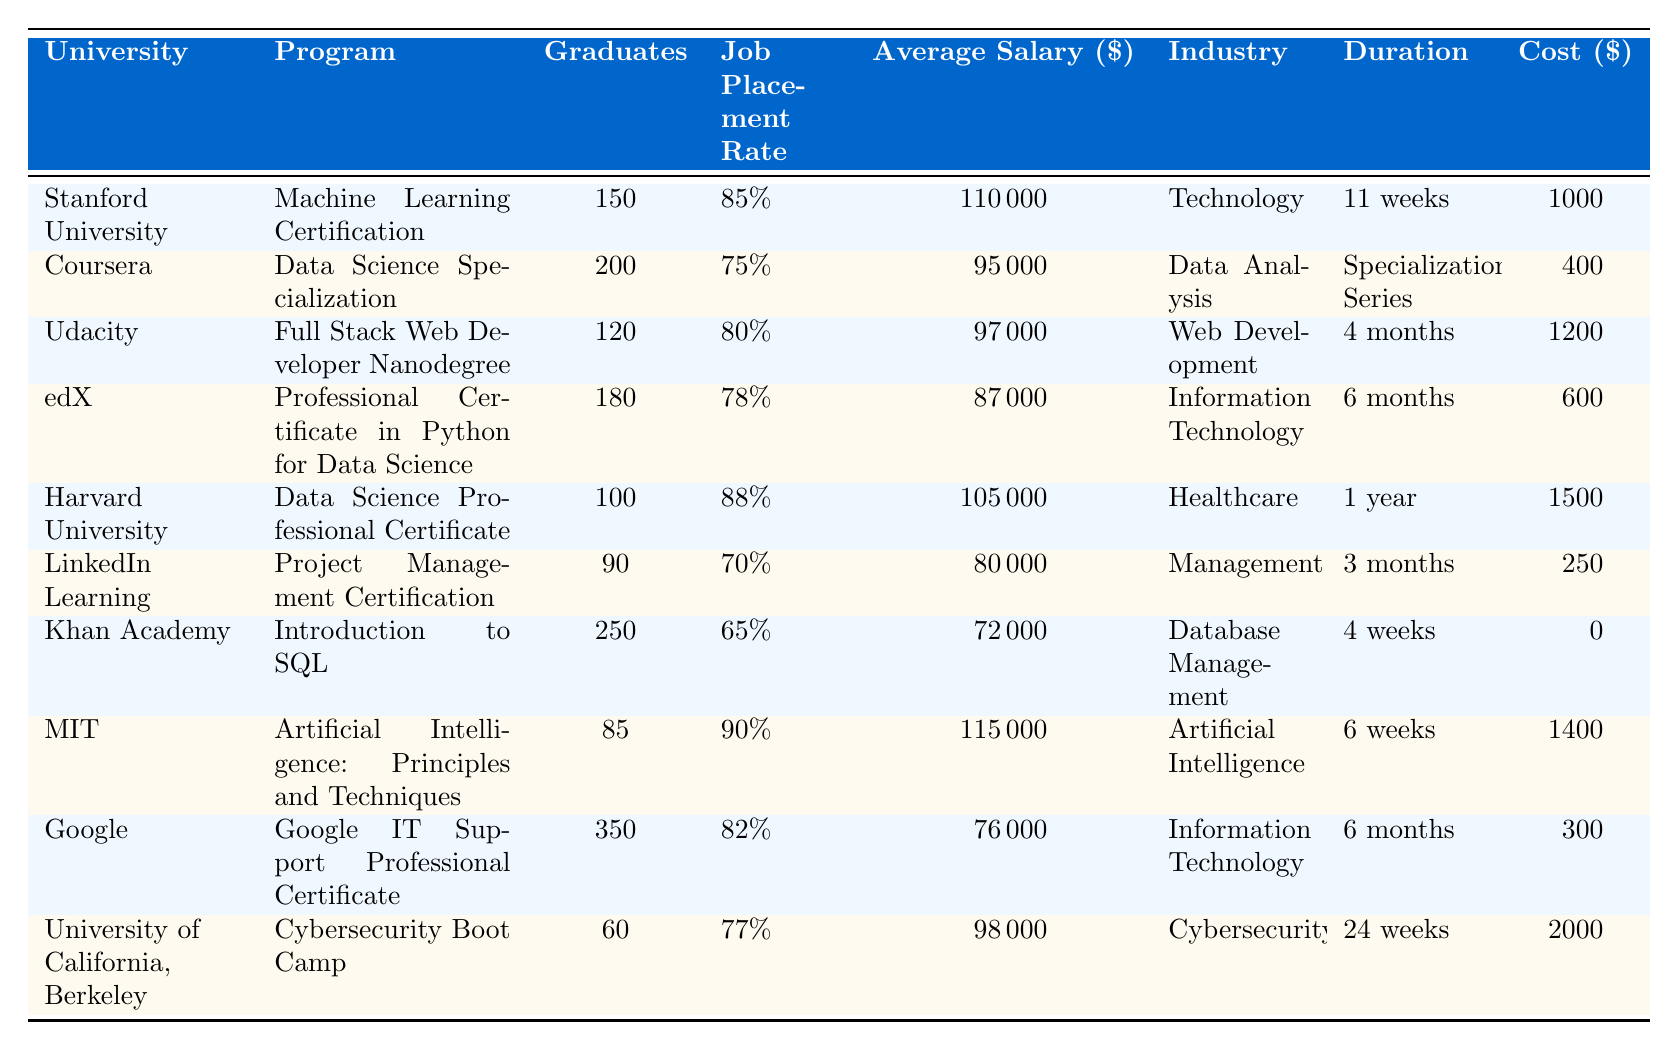What is the job placement rate for the Machine Learning Certification program? The job placement rate for the Machine Learning Certification program at Stanford University can be found directly in the corresponding row of the table, which states the rate is 85%.
Answer: 85% Which program has the highest average salary? By reviewing the average salaries across all programs, the highest one is for the Artificial Intelligence program at MIT, which is $115,000.
Answer: $115,000 What is the average job placement rate for the programs offered by edX and LinkedIn Learning? The job placement rates for edX and LinkedIn Learning are 78% and 70%, respectively. To find the average, we add them together (78 + 70 = 148) and then divide by 2, resulting in 74%.
Answer: 74% Is the duration of the Data Science Specialization longer than that of the Machine Learning Certification? The duration of the Data Science Specialization is listed as a "Specialization Series," while the Machine Learning Certification is 11 weeks. Without a specific week count for the Specialization, we cannot definitively compare these durations. Therefore, the answer is no, we cannot confirm that it is longer.
Answer: No How many graduates are there from the Google IT Support Professional Certificate program, and how does that compare to the Harvard Data Science Professional Certificate? The Google IT Support Professional Certificate has 350 graduates, while the Harvard Data Science Professional Certificate has 100 graduates. This shows that Google’s program has 250 more graduates than Harvard's.
Answer: 350 graduates (250 more than Harvard) What percentage of graduates from the Cybersecurity Boot Camp were placed in jobs? From the table, the job placement rate for the Cybersecurity Boot Camp is listed as 77%.
Answer: 77% What is the cost difference between the Cybersecurity Boot Camp and the Data Science Specialization? The cost of the Cybersecurity Boot Camp is $2000 and the Data Science Specialization is $400. The difference is calculated as $2000 - $400 = $1600.
Answer: $1600 Which industry has the lowest job placement rate and what is that rate? The table shows that the program with the lowest job placement rate is "Introduction to SQL" at Khan Academy with a rate of 65%.
Answer: 65% If you combine the number of graduates from the Machine Learning Certification and the Full Stack Web Developer Nanodegree, what is the total? The Machine Learning Certification program has 150 graduates and the Full Stack Web Developer Nanodegree has 120 graduates. Adding these gives a total of 150 + 120 = 270 graduates.
Answer: 270 Is there any program that has no cost associated with it? Looking at the table, the Introduction to SQL program from Khan Academy has a cost of $0, indicating it is free.
Answer: Yes, Khan Academy's program is free 